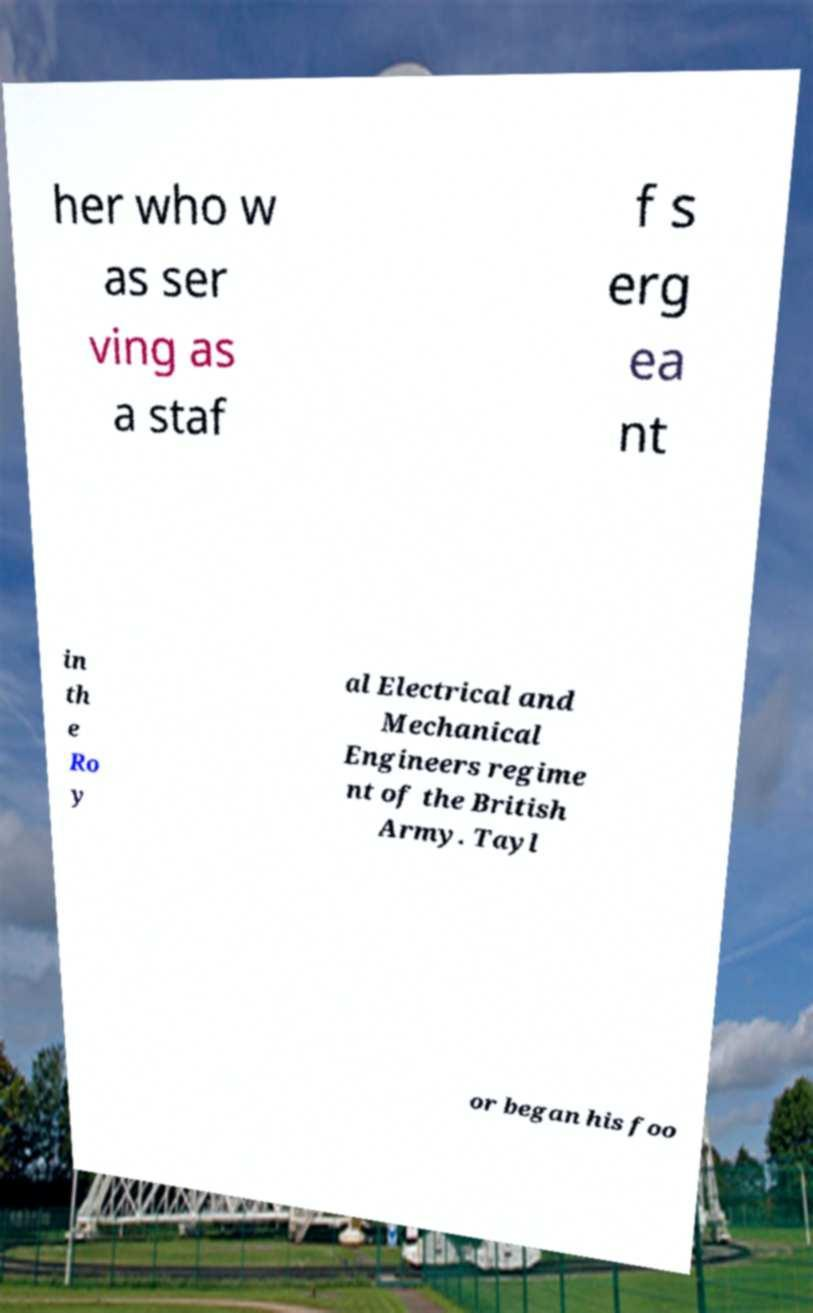I need the written content from this picture converted into text. Can you do that? her who w as ser ving as a staf f s erg ea nt in th e Ro y al Electrical and Mechanical Engineers regime nt of the British Army. Tayl or began his foo 